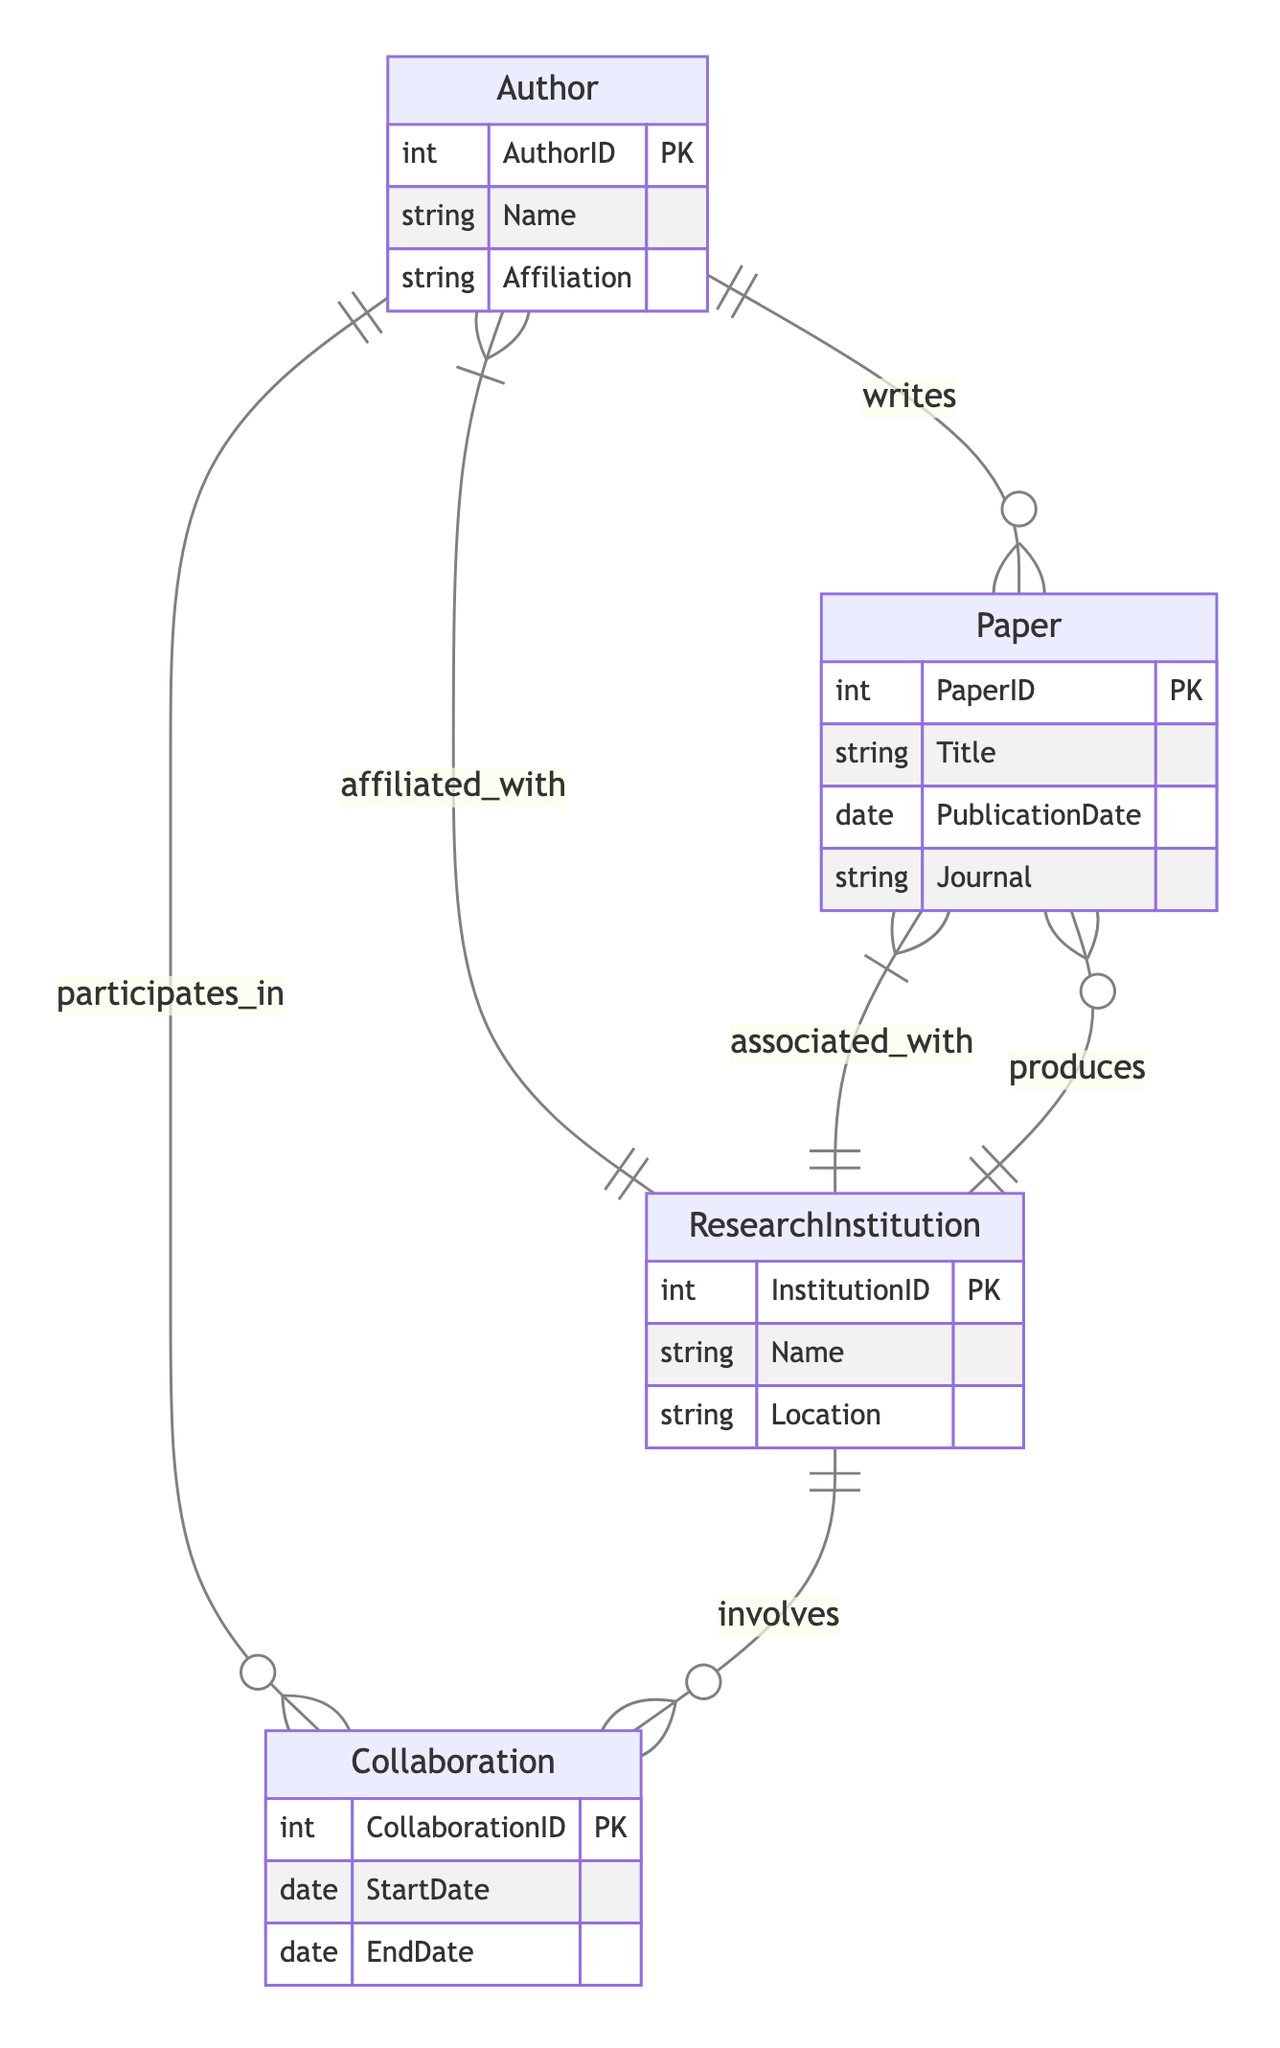What is the primary attribute of the Author entity? The Author entity has several attributes, among which the primary attribute is AuthorID, which uniquely identifies each author.
Answer: AuthorID How many relationships involve the Collaboration entity? The diagram showcases two relationships that involve the Collaboration entity: "Author_Collaboration" and "Institution_Collaboration." This indicates that authors and research institutions can both engage in collaborations.
Answer: 2 What type of relationship exists between Author and ResearchInstitution? The relationship between Author and ResearchInstitution is defined as "M:1," indicating that many authors can be affiliated with one research institution.
Answer: M:1 Which entities have a many-to-many relationship according to the diagram? The entities that have a many-to-many relationship are Author and Paper, as well as Author and Collaboration, and ResearchInstitution and Collaboration, allowing multiple authors to write multiple papers and participate in multiple collaborations.
Answer: Author and Paper; Author and Collaboration; ResearchInstitution and Collaboration How are Papers associated with Research Institutions in the diagram? Papers are associated with Research Institutions through a "M:1" relationship, signifying that many papers can be produced or published by one research institution.
Answer: M:1 What is the role of the Collaboration entity in the diagram? The Collaboration entity acts as a linking entity, connecting authors and research institutions through their respective collaborations, indicating their joint efforts in research initiatives.
Answer: Linking entity Which attribute uniquely identifies each Paper entity? The Paper entity is uniquely identified by the PaperID attribute, which distinguishes it from other papers in the network.
Answer: PaperID 